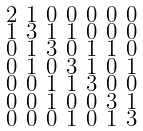Convert formula to latex. <formula><loc_0><loc_0><loc_500><loc_500>\begin{smallmatrix} 2 & 1 & 0 & 0 & 0 & 0 & 0 \\ 1 & 3 & 1 & 1 & 0 & 0 & 0 \\ 0 & 1 & 3 & 0 & 1 & 1 & 0 \\ 0 & 1 & 0 & 3 & 1 & 0 & 1 \\ 0 & 0 & 1 & 1 & 3 & 0 & 0 \\ 0 & 0 & 1 & 0 & 0 & 3 & 1 \\ 0 & 0 & 0 & 1 & 0 & 1 & 3 \end{smallmatrix}</formula> 